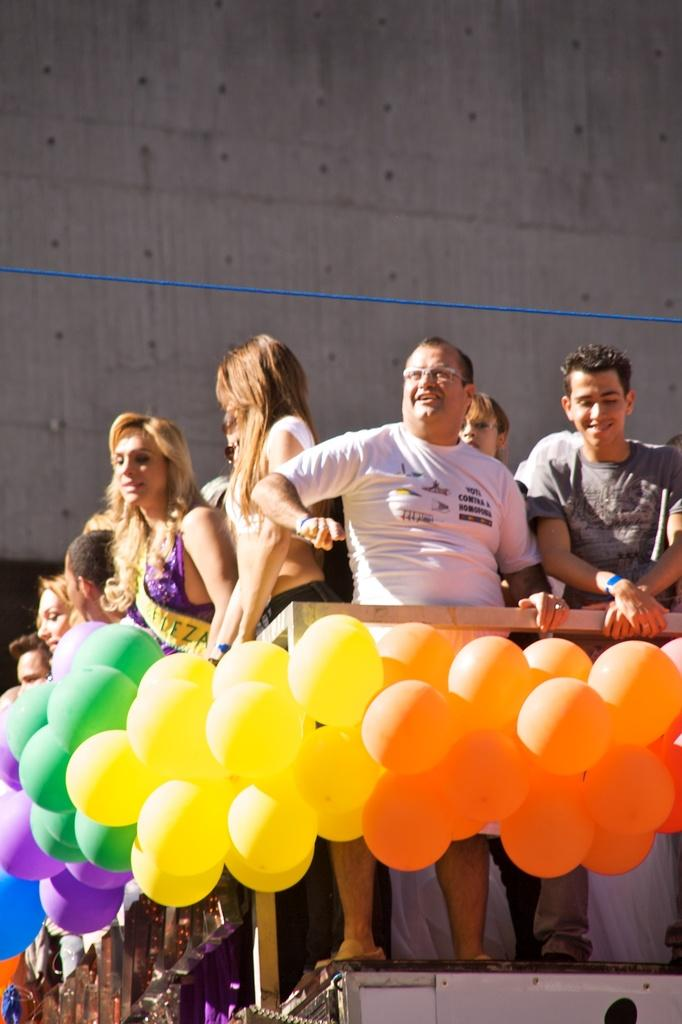What can be seen in the image? There are people standing in the image. What else is present in the image besides the people? There are balloons in the image. What can be seen in the background of the image? There is a wall in the background of the image. What type of coil is being used to create friction between the people in the image? There is no coil or friction present in the image; the people are simply standing. What organization is responsible for the event depicted in the image? The image does not provide enough information to determine which organization, if any, is responsible for the event. 